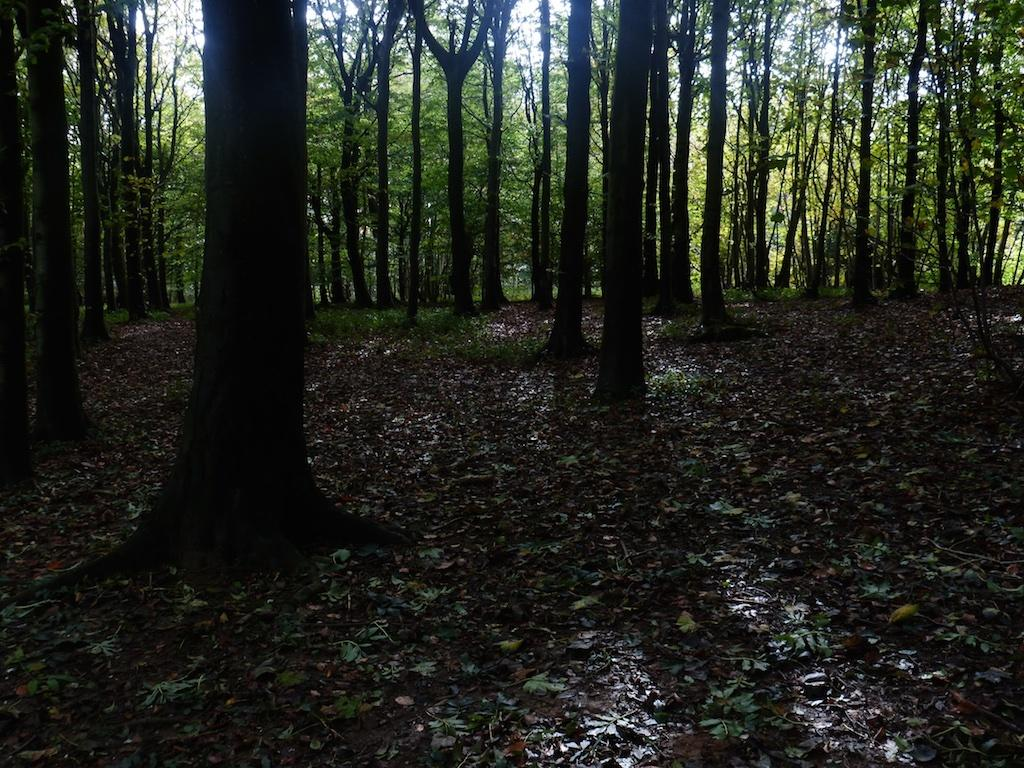What type of vegetation can be seen in the image? There are trees in the image. What part of the natural environment is visible on the ground? The ground is visible in the image. What type of plant life is present on the ground? There is grass in the image. What part of the natural environment is visible above the ground? The sky is visible in the image. What type of paint is used to color the trees in the image? There is no paint used in the image; the trees are naturally colored. Is there any oil visible in the image? There is no oil present in the image. 